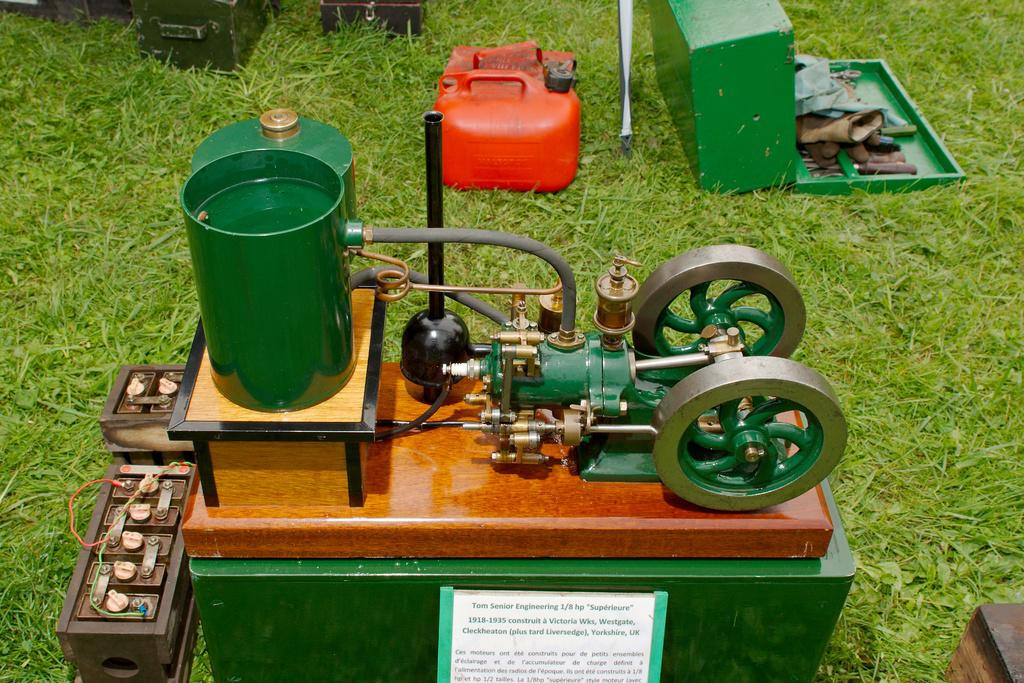What is the main object in the image? There is a machine in the image. What else can be seen in the image related to tools or equipment? There is a tool box in the image. What color is the container in the image? The container in the image is red. Where are the machine, tool box, and red container located? They are on the grass in the image. Can you describe any other unspecified items in the image? Unfortunately, the facts provided do not specify any other items in the image. What type of wave can be seen crashing on the shore in the image? There is no wave or shore present in the image; it features a machine, tool box, and red container on the grass. 